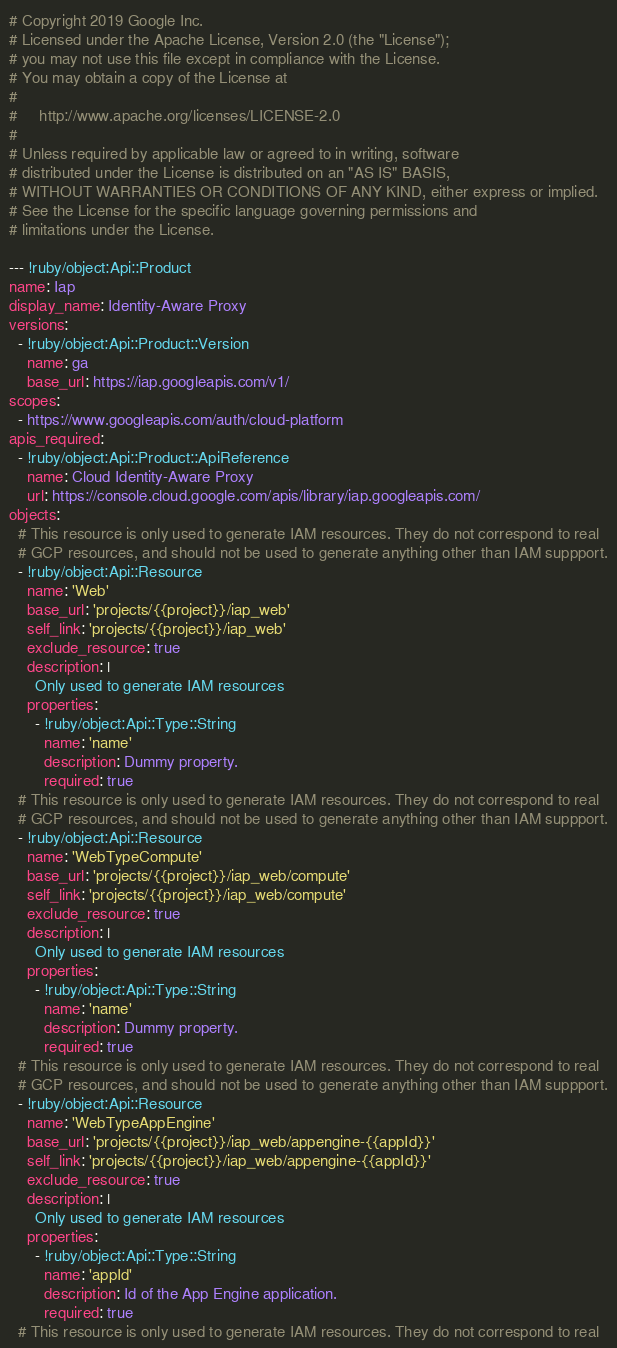<code> <loc_0><loc_0><loc_500><loc_500><_YAML_># Copyright 2019 Google Inc.
# Licensed under the Apache License, Version 2.0 (the "License");
# you may not use this file except in compliance with the License.
# You may obtain a copy of the License at
#
#     http://www.apache.org/licenses/LICENSE-2.0
#
# Unless required by applicable law or agreed to in writing, software
# distributed under the License is distributed on an "AS IS" BASIS,
# WITHOUT WARRANTIES OR CONDITIONS OF ANY KIND, either express or implied.
# See the License for the specific language governing permissions and
# limitations under the License.

--- !ruby/object:Api::Product
name: Iap
display_name: Identity-Aware Proxy
versions:
  - !ruby/object:Api::Product::Version
    name: ga
    base_url: https://iap.googleapis.com/v1/
scopes:
  - https://www.googleapis.com/auth/cloud-platform
apis_required:
  - !ruby/object:Api::Product::ApiReference
    name: Cloud Identity-Aware Proxy
    url: https://console.cloud.google.com/apis/library/iap.googleapis.com/
objects:
  # This resource is only used to generate IAM resources. They do not correspond to real
  # GCP resources, and should not be used to generate anything other than IAM suppport.
  - !ruby/object:Api::Resource
    name: 'Web'
    base_url: 'projects/{{project}}/iap_web'
    self_link: 'projects/{{project}}/iap_web'
    exclude_resource: true
    description: |
      Only used to generate IAM resources
    properties:
      - !ruby/object:Api::Type::String
        name: 'name'
        description: Dummy property.
        required: true
  # This resource is only used to generate IAM resources. They do not correspond to real
  # GCP resources, and should not be used to generate anything other than IAM suppport.
  - !ruby/object:Api::Resource
    name: 'WebTypeCompute'
    base_url: 'projects/{{project}}/iap_web/compute'
    self_link: 'projects/{{project}}/iap_web/compute'
    exclude_resource: true
    description: |
      Only used to generate IAM resources
    properties:
      - !ruby/object:Api::Type::String
        name: 'name'
        description: Dummy property.
        required: true
  # This resource is only used to generate IAM resources. They do not correspond to real
  # GCP resources, and should not be used to generate anything other than IAM suppport.
  - !ruby/object:Api::Resource
    name: 'WebTypeAppEngine'
    base_url: 'projects/{{project}}/iap_web/appengine-{{appId}}'
    self_link: 'projects/{{project}}/iap_web/appengine-{{appId}}'
    exclude_resource: true
    description: |
      Only used to generate IAM resources
    properties:
      - !ruby/object:Api::Type::String
        name: 'appId'
        description: Id of the App Engine application.
        required: true
  # This resource is only used to generate IAM resources. They do not correspond to real</code> 